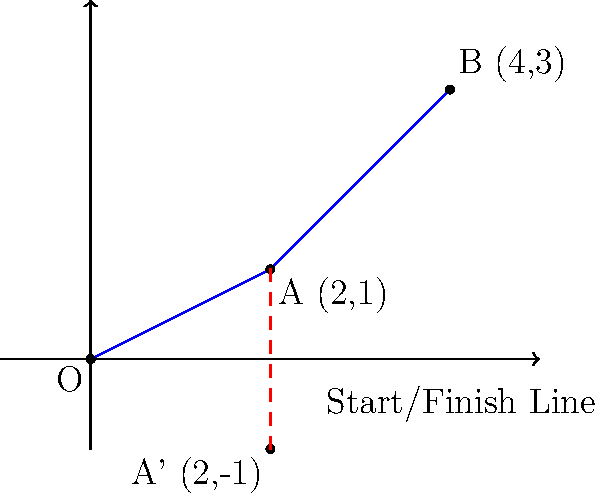A motorcycle starts at point A(2,1) and moves to point B(4,3) on a speedway track. If the motorcycle's initial position is reflected across the start/finish line (x-axis), what are the coordinates of the reflected point A'? To solve this problem, we need to apply the concept of reflection across the x-axis:

1. The x-coordinate remains the same during reflection across the x-axis.
2. The y-coordinate changes sign (positive becomes negative and vice versa).

Given:
- Initial point A(2,1)
- The reflection is across the x-axis (y = 0)

Steps:
1. Keep the x-coordinate the same: x' = 2
2. Change the sign of the y-coordinate: y' = -1

Therefore, the coordinates of the reflected point A' are (2, -1).
Answer: A'(2, -1) 